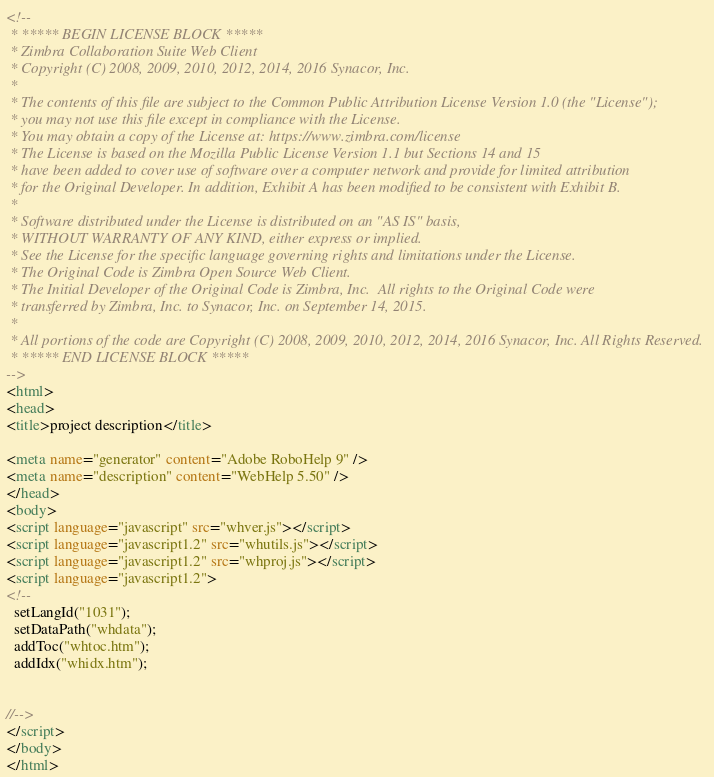<code> <loc_0><loc_0><loc_500><loc_500><_HTML_><!--
 * ***** BEGIN LICENSE BLOCK *****
 * Zimbra Collaboration Suite Web Client
 * Copyright (C) 2008, 2009, 2010, 2012, 2014, 2016 Synacor, Inc.
 *
 * The contents of this file are subject to the Common Public Attribution License Version 1.0 (the "License");
 * you may not use this file except in compliance with the License.
 * You may obtain a copy of the License at: https://www.zimbra.com/license
 * The License is based on the Mozilla Public License Version 1.1 but Sections 14 and 15
 * have been added to cover use of software over a computer network and provide for limited attribution
 * for the Original Developer. In addition, Exhibit A has been modified to be consistent with Exhibit B.
 *
 * Software distributed under the License is distributed on an "AS IS" basis,
 * WITHOUT WARRANTY OF ANY KIND, either express or implied.
 * See the License for the specific language governing rights and limitations under the License.
 * The Original Code is Zimbra Open Source Web Client.
 * The Initial Developer of the Original Code is Zimbra, Inc.  All rights to the Original Code were
 * transferred by Zimbra, Inc. to Synacor, Inc. on September 14, 2015.
 *
 * All portions of the code are Copyright (C) 2008, 2009, 2010, 2012, 2014, 2016 Synacor, Inc. All Rights Reserved.
 * ***** END LICENSE BLOCK *****
-->
<html>
<head>
<title>project description</title>

<meta name="generator" content="Adobe RoboHelp 9" />
<meta name="description" content="WebHelp 5.50" />
</head>
<body>
<script language="javascript" src="whver.js"></script>
<script language="javascript1.2" src="whutils.js"></script>
<script language="javascript1.2" src="whproj.js"></script>
<script language="javascript1.2">
<!--
  setLangId("1031");
  setDataPath("whdata");
  addToc("whtoc.htm");
  addIdx("whidx.htm");


//-->
</script>
</body>
</html></code> 